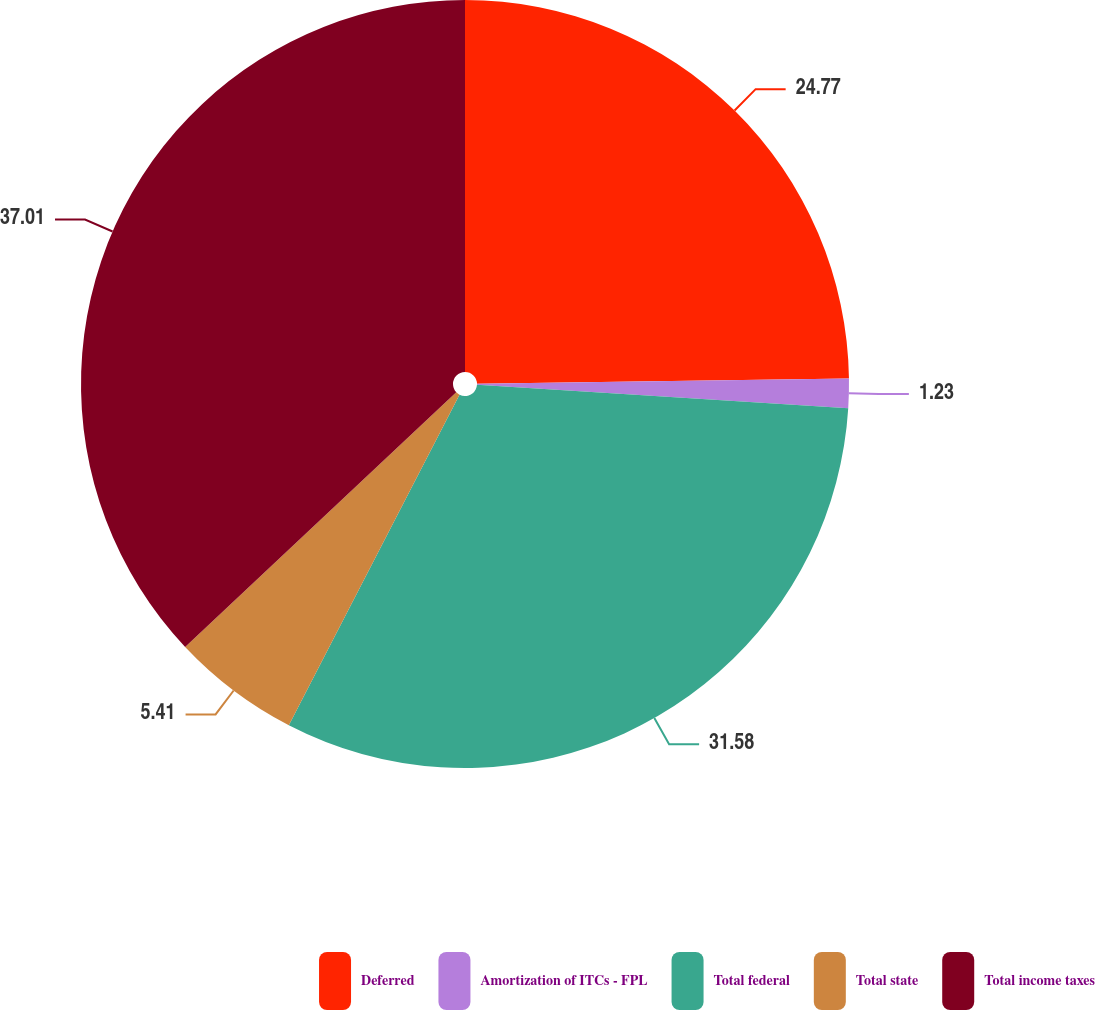Convert chart. <chart><loc_0><loc_0><loc_500><loc_500><pie_chart><fcel>Deferred<fcel>Amortization of ITCs - FPL<fcel>Total federal<fcel>Total state<fcel>Total income taxes<nl><fcel>24.77%<fcel>1.23%<fcel>31.58%<fcel>5.41%<fcel>37.0%<nl></chart> 